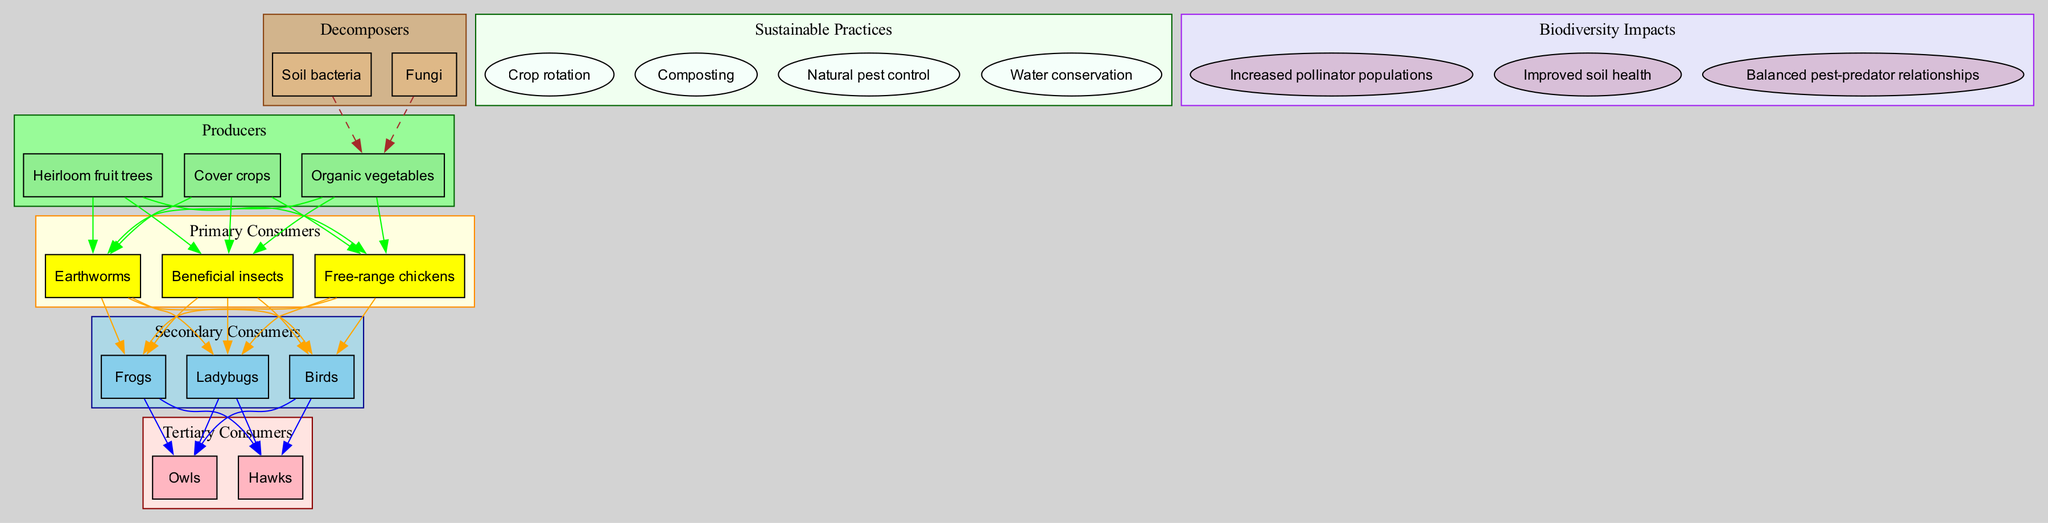What is the top level of consumers in this food chain? The top level of consumers in this food chain is represented by the tertiary consumers, which include owls and hawks. These are the predators that sit at the highest trophic level in the diagram.
Answer: Tertiary consumers How many types of primary consumers are there? To find the number of primary consumers, we can count the nodes listed under "Primary Consumers." There are three types: beneficial insects, free-range chickens, and earthworms.
Answer: 3 What sustainable practice is used for pest control? Looking at the sustainable practices listed in the diagram, "Natural pest control" directly addresses ways to manage pests sustainably on the farm.
Answer: Natural pest control Which decomposer is linked to the producers? In the diagram, a dashed edge connects the decomposers to the producers. Looking closely, we find that soil bacteria connects to organic vegetables specifically as part of decomposition.
Answer: Soil bacteria What impact does Warren's farming have on pollinator populations? The diagram indicates that one of the biodiversity impacts is "Increased pollinator populations," implying that the practices enhance the conditions for pollinators on the farm, showing environmental benefits.
Answer: Increased pollinator populations Which primary consumer is a bird? Among the primary consumers listed in the dataset, none are explicitly a bird, however, "free-range chickens" are a type of bird and fit into that category.
Answer: Free-range chickens What is the relationship between secondary consumers and tertiary consumers? The diagram shows that secondary consumers, such as ladybugs and birds, are preyed upon by tertiary consumers, owls, and hawks. Therefore, there is a direct predator-prey relationship between these two groups.
Answer: Predator-prey relationship What is one way Warren improves soil health? Looking at the sustainable practices, "Composting" contributes significantly to improving soil health by returning nutrients back into the soil, thus enhancing its fertility.
Answer: Composting 